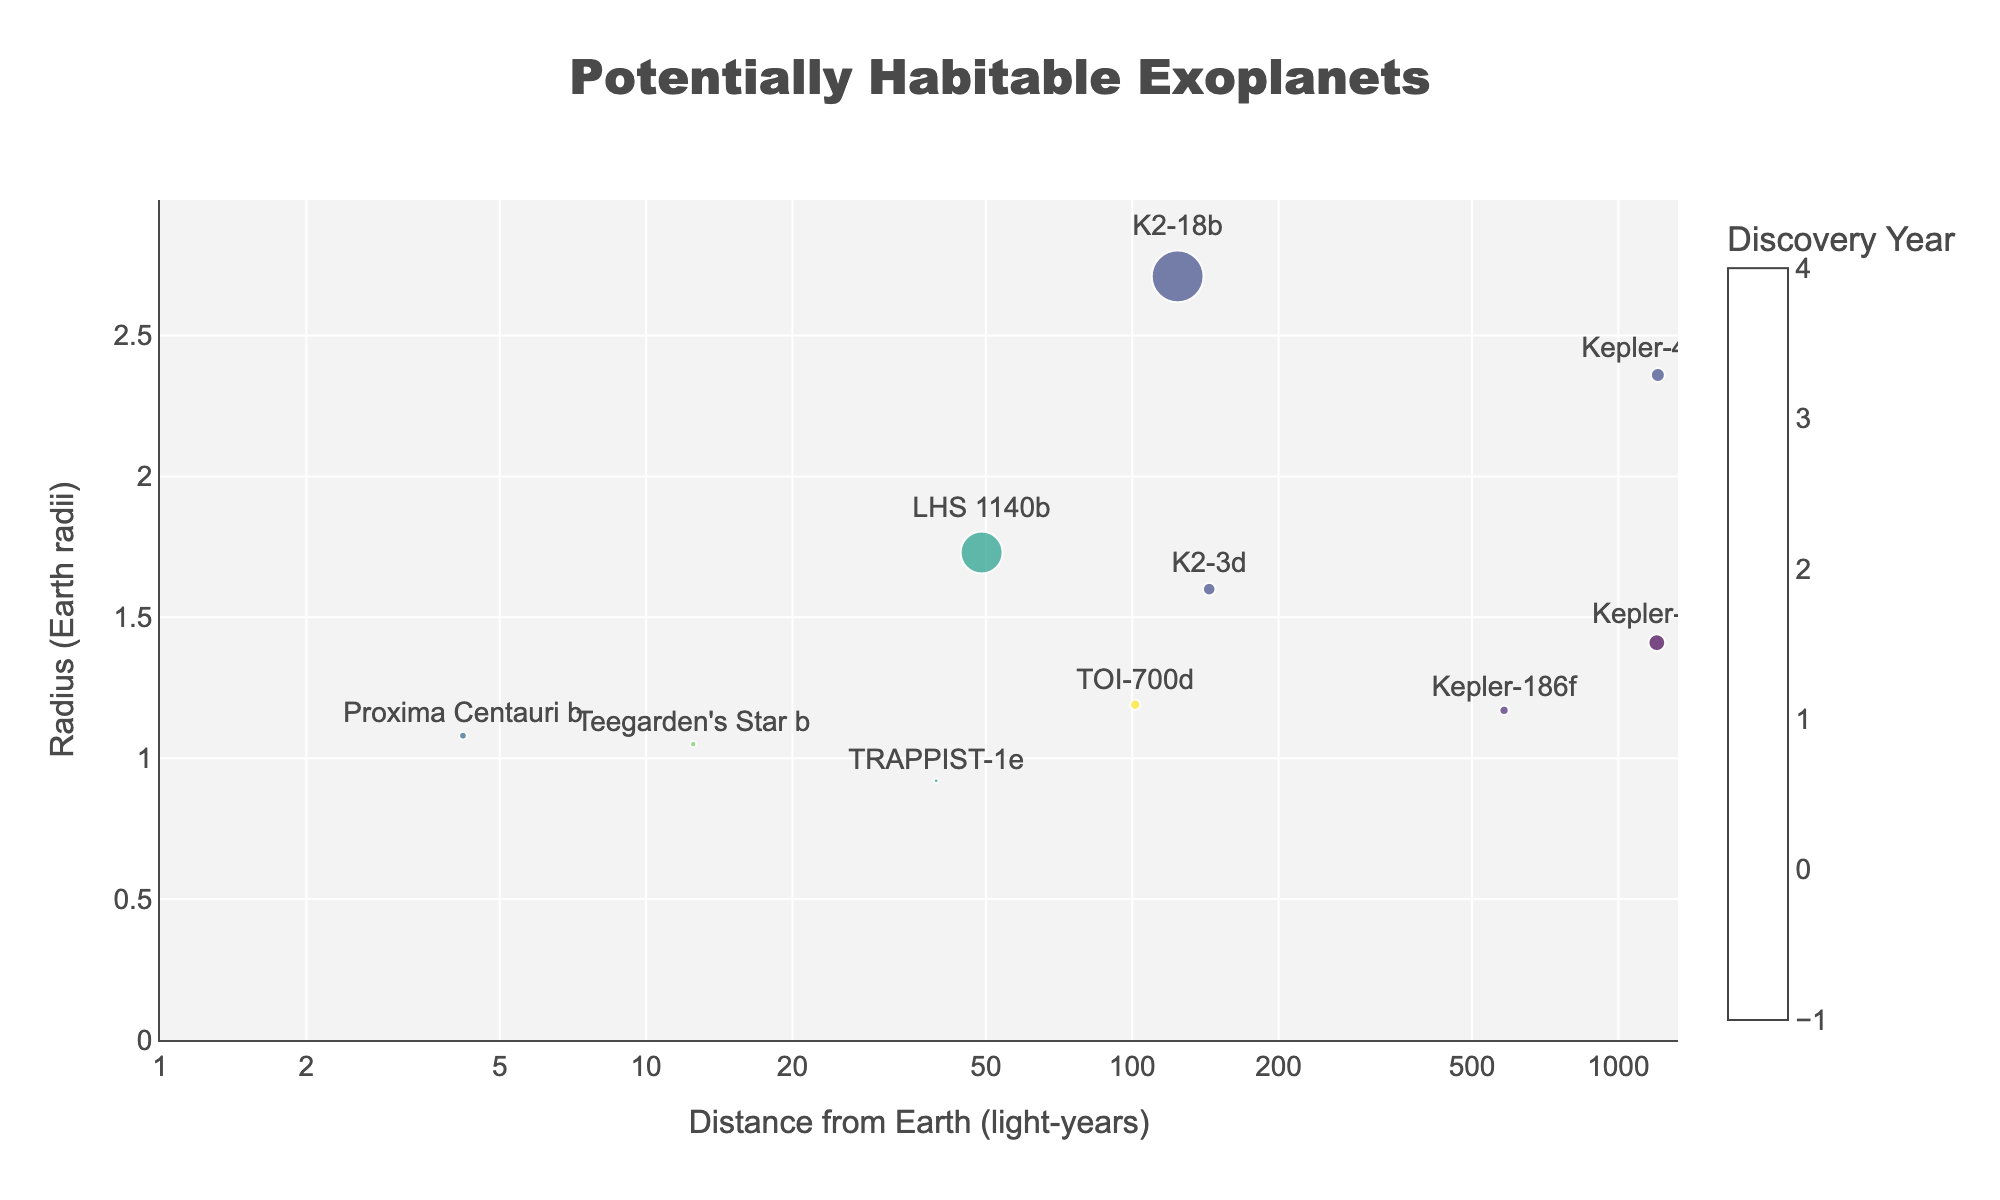What's the title of the figure? The title is displayed at the top of the figure and describes what the plot is about. In this case, it states "Potentially Habitable Exoplanets" which indicates the content of the plot.
Answer: Potentially Habitable Exoplanets What are the x-axis and y-axis labels? The x-axis label is shown at the bottom of the horizontal axis, and the y-axis label is shown alongside the vertical axis. The x-axis is labeled "Distance from Earth (light-years)" and the y-axis is labeled "Radius (Earth radii)".
Answer: Distance from Earth (light-years) and Radius (Earth radii) Which exoplanet is the closest to Earth? By looking at the x-axis, the exoplanet with the smallest distance value is Proxima Centauri b, located in the Proxima Centauri star system, with a distance of 4.2 light-years from Earth.
Answer: Proxima Centauri b Which exoplanet has the largest radius and what is its value? Observing the y-axis, the exoplanet with the largest radius is K2-18b, with a radius of 2.71 Earth radii.
Answer: K2-18b, 2.71 Earth radii Which exoplanet was discovered the most recently and in which year? The color scale indicates discovery years, where a lighter color represents more recent discovery times. TOI-700d has the lightest color and was discovered in 2020.
Answer: TOI-700d, 2020 What is the typical size relationship between the plotted points and the exoplanets' masses? The size of each marker in the plot corresponds to the exoplanet's mass. Larger markers indicate larger masses. This means K2-18b, with the largest marker, has the largest mass, which is 8.63 Earth masses.
Answer: Larger markers indicate larger masses Compare the distances between Kepler-62f and Kepler-442b. Which one is farther from Earth? By comparing the x-axis values, Kepler-62f (1200 light-years) is farther from Earth than Kepler-442b (1206 light-years).
Answer: Kepler-442b Are there more exoplanets discovered before or after 2016? Observing the color scale, the points corresponding to years before 2016 are in darker shades, while those discovered after 2016 are in lighter shades. There are 5 exoplanets discovered before 2016 and 5 after 2016. Thus, both periods have the same number of discovered exoplanets.
Answer: Equal What is the maximum radius among the exoplanets discovered in 2017? Identifying the exoplanets discovered in 2017, which are TRAPPIST-1e and LHS 1140b, LHS 1140b has the largest radius of 1.73 Earth radii.
Answer: 1.73 Earth radii Which exoplanet discovered in 2015 has the smaller mass? Among the exoplanets discovered in 2015 (Kepler-442b, K2-18b, K2-3d), K2-3d has the smallest mass, which is 2.1 Earth masses.
Answer: K2-3d, 2.1 Earth masses 